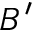<formula> <loc_0><loc_0><loc_500><loc_500>B ^ { \prime }</formula> 